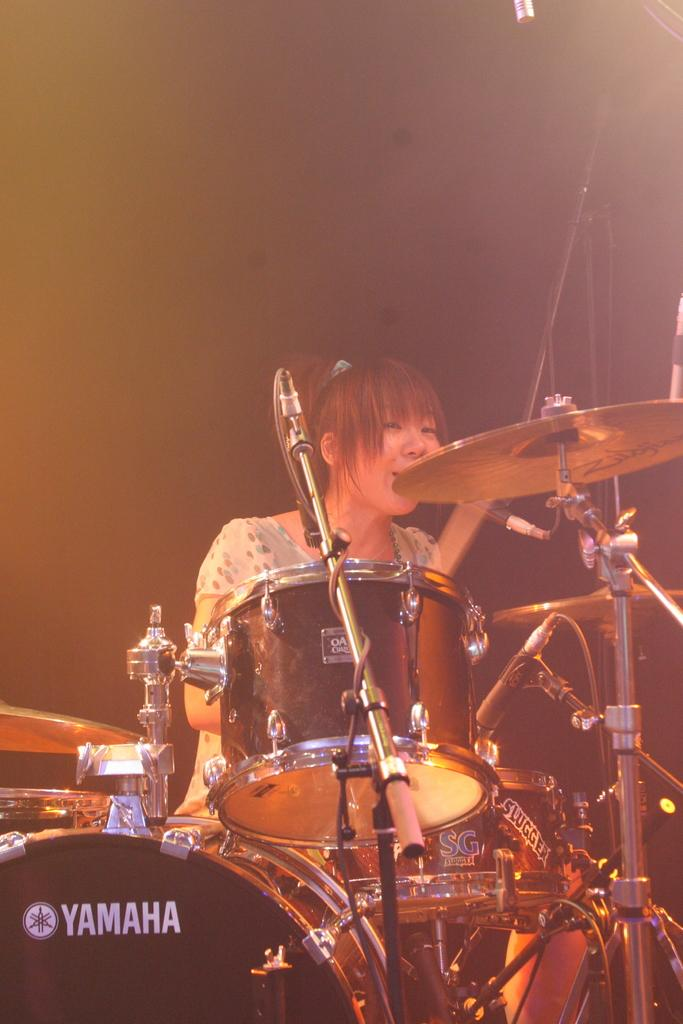What is the person in the image holding? The person in the image is holding sticks. What type of musical instruments can be seen in the image? There are drums and other musical instruments in the image. What devices are present for amplifying sound? There are microphones in the image. What can be seen in the background of the image? There are objects visible in the background of the image. How does the duck contribute to the music in the image? There is no duck present in the image, so it cannot contribute to the music. 